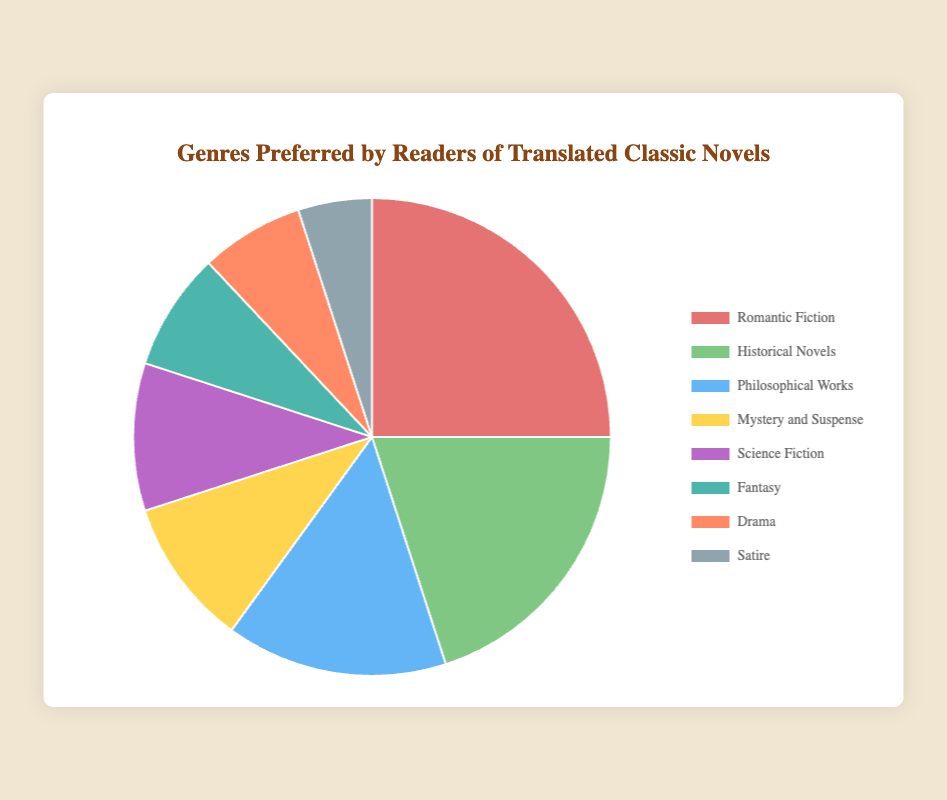Which genre is preferred by the largest percentage of readers? The figure lists the percentage of readers for each genre. By examining the data, we see that Romantic Fiction is preferred by 25%, which is the highest among all genres.
Answer: Romantic Fiction Which two genres have the smallest percentage of readers combined? The two genres with the smallest percentages are Drama (7%) and Satire (5%). Their combined percentage is 7% + 5% = 12%.
Answer: 12% How does the percentage of readers preferring Historical Novels compare to those preferring Fantasy? The figure shows that Historical Novels are preferred by 20% of readers, while Fantasy is preferred by 8%. 20% is more than 8%.
Answer: Historical Novels are preferred more What is the combined percentage of readers for Philosophical Works, Mystery and Suspense, and Science Fiction? Philosophical Works have 15%, Mystery and Suspense have 10%, and Science Fiction has 10%. Adding these gives 15% + 10% + 10% = 35%.
Answer: 35% What percentage of readers prefer genres that have a percentage below 10%? The genres with percentages below 10% are Fantasy (8%), Drama (7%), and Satire (5%). Adding these gives 8% + 7% + 5% = 20%.
Answer: 20% Is the percentage of readers for Science Fiction equal to the sum of the percentages for Drama and Satire? The percentage for Science Fiction is 10%. The percentage for Drama is 7% and for Satire is 5%. The sum of Drama and Satire is 7% + 5% = 12%, which is greater than 10%.
Answer: No What is the difference in percentage between the most and least preferred genres? The most preferred genre is Romantic Fiction with 25%, and the least preferred is Satire with 5%. The difference is 25% - 5% = 20%.
Answer: 20% If we group Mystery and Suspense, Science Fiction, and Fantasy together, what percentage of readers do they represent? Mystery and Suspense have 10%, Science Fiction also has 10%, and Fantasy has 8%. Adding these gives 10% + 10% + 8% = 28%.
Answer: 28% Identify the genre marked in green and its percentage. In the figure, we observe that Historical Novels is marked in green with a percentage of 20%.
Answer: Historical Novels, 20% 